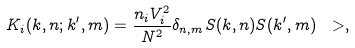Convert formula to latex. <formula><loc_0><loc_0><loc_500><loc_500>K _ { i } ( { k } , n ; { k ^ { \prime } } , m ) = \frac { n _ { i } V _ { i } ^ { 2 } } { N ^ { 2 } } \delta _ { n , m } S ( { k } , n ) S ( { k ^ { \prime } } , m ) \ > ,</formula> 